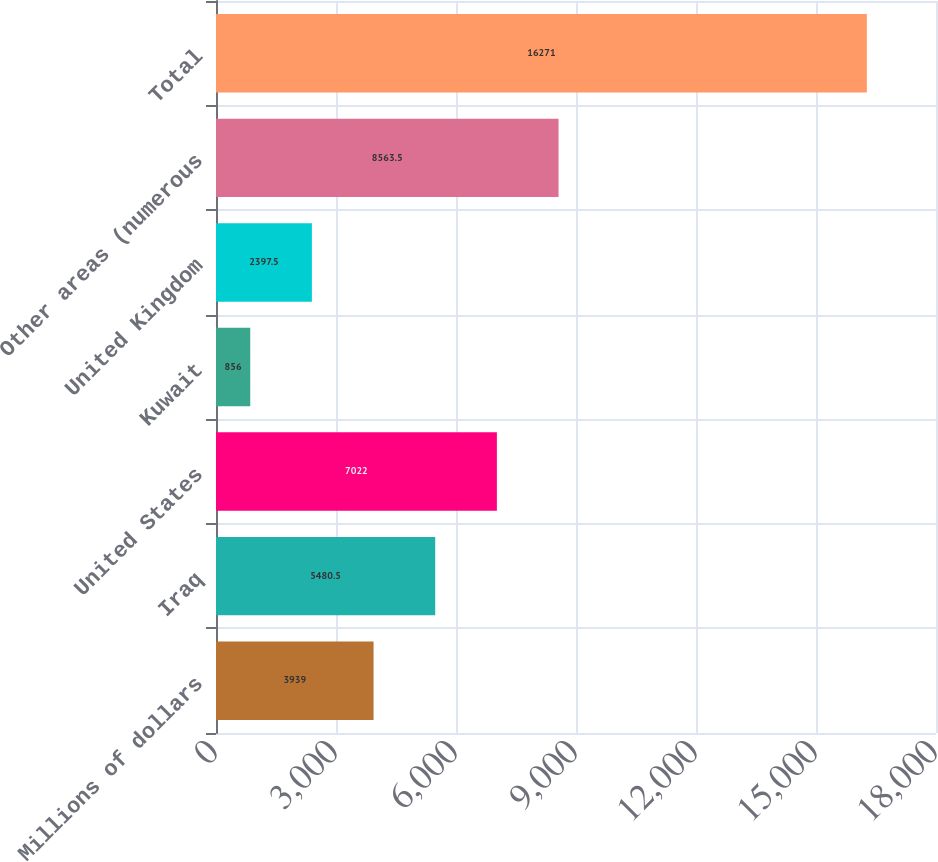Convert chart. <chart><loc_0><loc_0><loc_500><loc_500><bar_chart><fcel>Millions of dollars<fcel>Iraq<fcel>United States<fcel>Kuwait<fcel>United Kingdom<fcel>Other areas (numerous<fcel>Total<nl><fcel>3939<fcel>5480.5<fcel>7022<fcel>856<fcel>2397.5<fcel>8563.5<fcel>16271<nl></chart> 